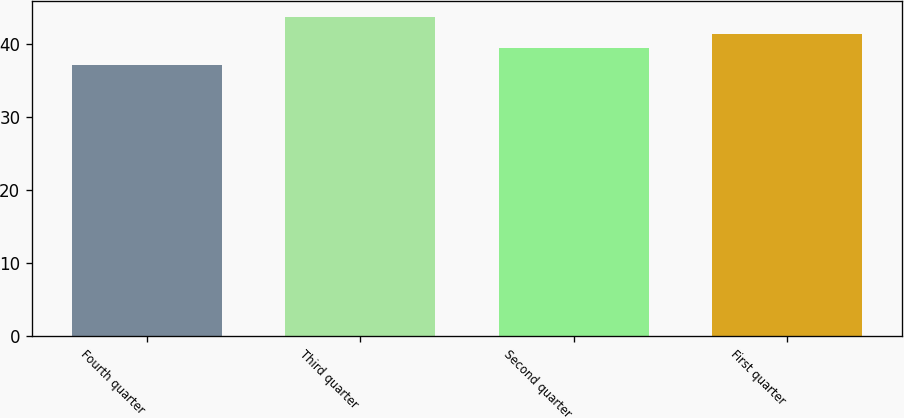Convert chart to OTSL. <chart><loc_0><loc_0><loc_500><loc_500><bar_chart><fcel>Fourth quarter<fcel>Third quarter<fcel>Second quarter<fcel>First quarter<nl><fcel>37.05<fcel>43.61<fcel>39.41<fcel>41.26<nl></chart> 